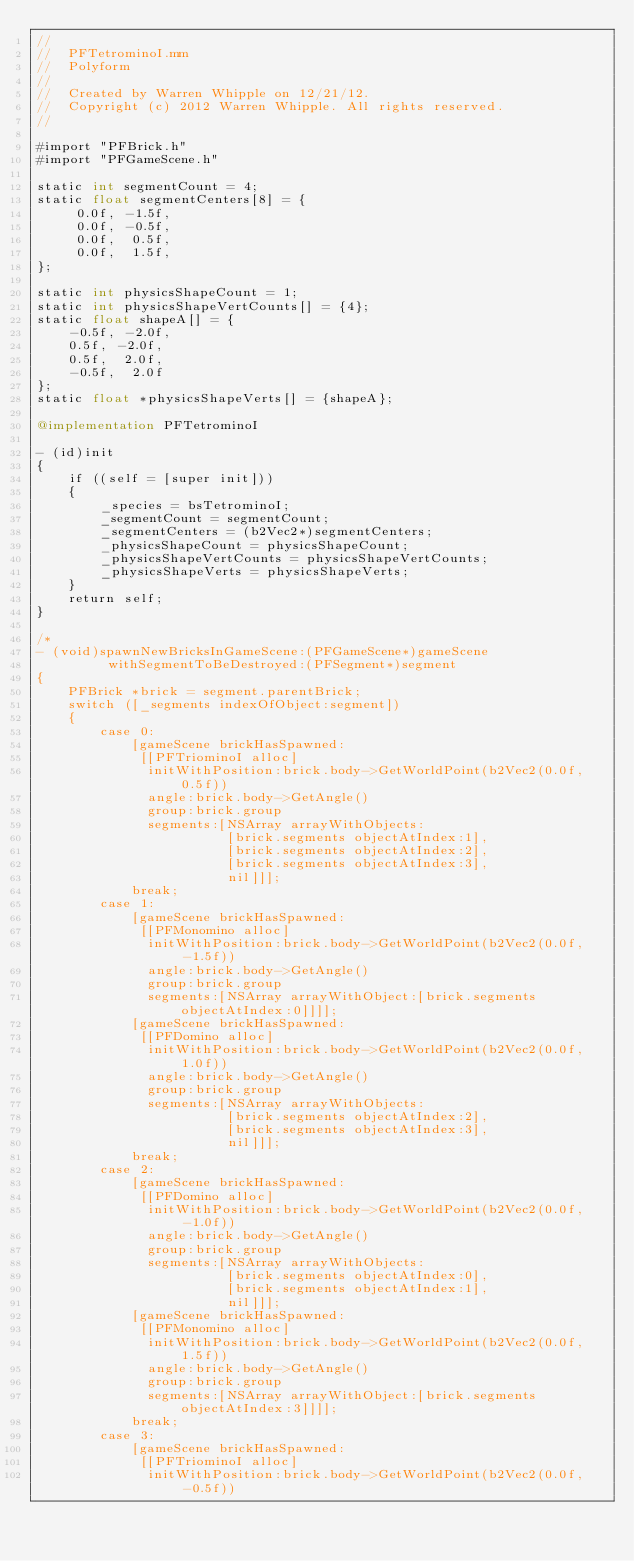Convert code to text. <code><loc_0><loc_0><loc_500><loc_500><_ObjectiveC_>//
//  PFTetrominoI.mm
//  Polyform
//
//  Created by Warren Whipple on 12/21/12.
//  Copyright (c) 2012 Warren Whipple. All rights reserved.
//

#import "PFBrick.h"
#import "PFGameScene.h"

static int segmentCount = 4;
static float segmentCenters[8] = {
     0.0f, -1.5f,
     0.0f, -0.5f,
     0.0f,  0.5f,
     0.0f,  1.5f,
};

static int physicsShapeCount = 1;
static int physicsShapeVertCounts[] = {4};
static float shapeA[] = {
    -0.5f, -2.0f,
    0.5f, -2.0f,
    0.5f,  2.0f,
    -0.5f,  2.0f
};
static float *physicsShapeVerts[] = {shapeA};

@implementation PFTetrominoI

- (id)init
{
    if ((self = [super init]))
    {
        _species = bsTetrominoI;
        _segmentCount = segmentCount;
        _segmentCenters = (b2Vec2*)segmentCenters;
        _physicsShapeCount = physicsShapeCount;
        _physicsShapeVertCounts = physicsShapeVertCounts;
        _physicsShapeVerts = physicsShapeVerts;
    }
    return self;
}

/*
- (void)spawnNewBricksInGameScene:(PFGameScene*)gameScene
         withSegmentToBeDestroyed:(PFSegment*)segment
{
    PFBrick *brick = segment.parentBrick;
    switch ([_segments indexOfObject:segment])
    {
        case 0:
            [gameScene brickHasSpawned:
             [[PFTriominoI alloc]
              initWithPosition:brick.body->GetWorldPoint(b2Vec2(0.0f, 0.5f))
              angle:brick.body->GetAngle()
              group:brick.group
              segments:[NSArray arrayWithObjects:
                        [brick.segments objectAtIndex:1],
                        [brick.segments objectAtIndex:2],
                        [brick.segments objectAtIndex:3],
                        nil]]];
            break;
        case 1:
            [gameScene brickHasSpawned:
             [[PFMonomino alloc]
              initWithPosition:brick.body->GetWorldPoint(b2Vec2(0.0f, -1.5f))
              angle:brick.body->GetAngle()
              group:brick.group
              segments:[NSArray arrayWithObject:[brick.segments objectAtIndex:0]]]];
            [gameScene brickHasSpawned:
             [[PFDomino alloc]
              initWithPosition:brick.body->GetWorldPoint(b2Vec2(0.0f, 1.0f))
              angle:brick.body->GetAngle()
              group:brick.group
              segments:[NSArray arrayWithObjects:
                        [brick.segments objectAtIndex:2],
                        [brick.segments objectAtIndex:3],
                        nil]]];
            break;
        case 2:
            [gameScene brickHasSpawned:
             [[PFDomino alloc]
              initWithPosition:brick.body->GetWorldPoint(b2Vec2(0.0f, -1.0f))
              angle:brick.body->GetAngle()
              group:brick.group
              segments:[NSArray arrayWithObjects:
                        [brick.segments objectAtIndex:0],
                        [brick.segments objectAtIndex:1],
                        nil]]];
            [gameScene brickHasSpawned:
             [[PFMonomino alloc]
              initWithPosition:brick.body->GetWorldPoint(b2Vec2(0.0f, 1.5f))
              angle:brick.body->GetAngle()
              group:brick.group
              segments:[NSArray arrayWithObject:[brick.segments objectAtIndex:3]]]];
            break;
        case 3:
            [gameScene brickHasSpawned:
             [[PFTriominoI alloc]
              initWithPosition:brick.body->GetWorldPoint(b2Vec2(0.0f, -0.5f))</code> 